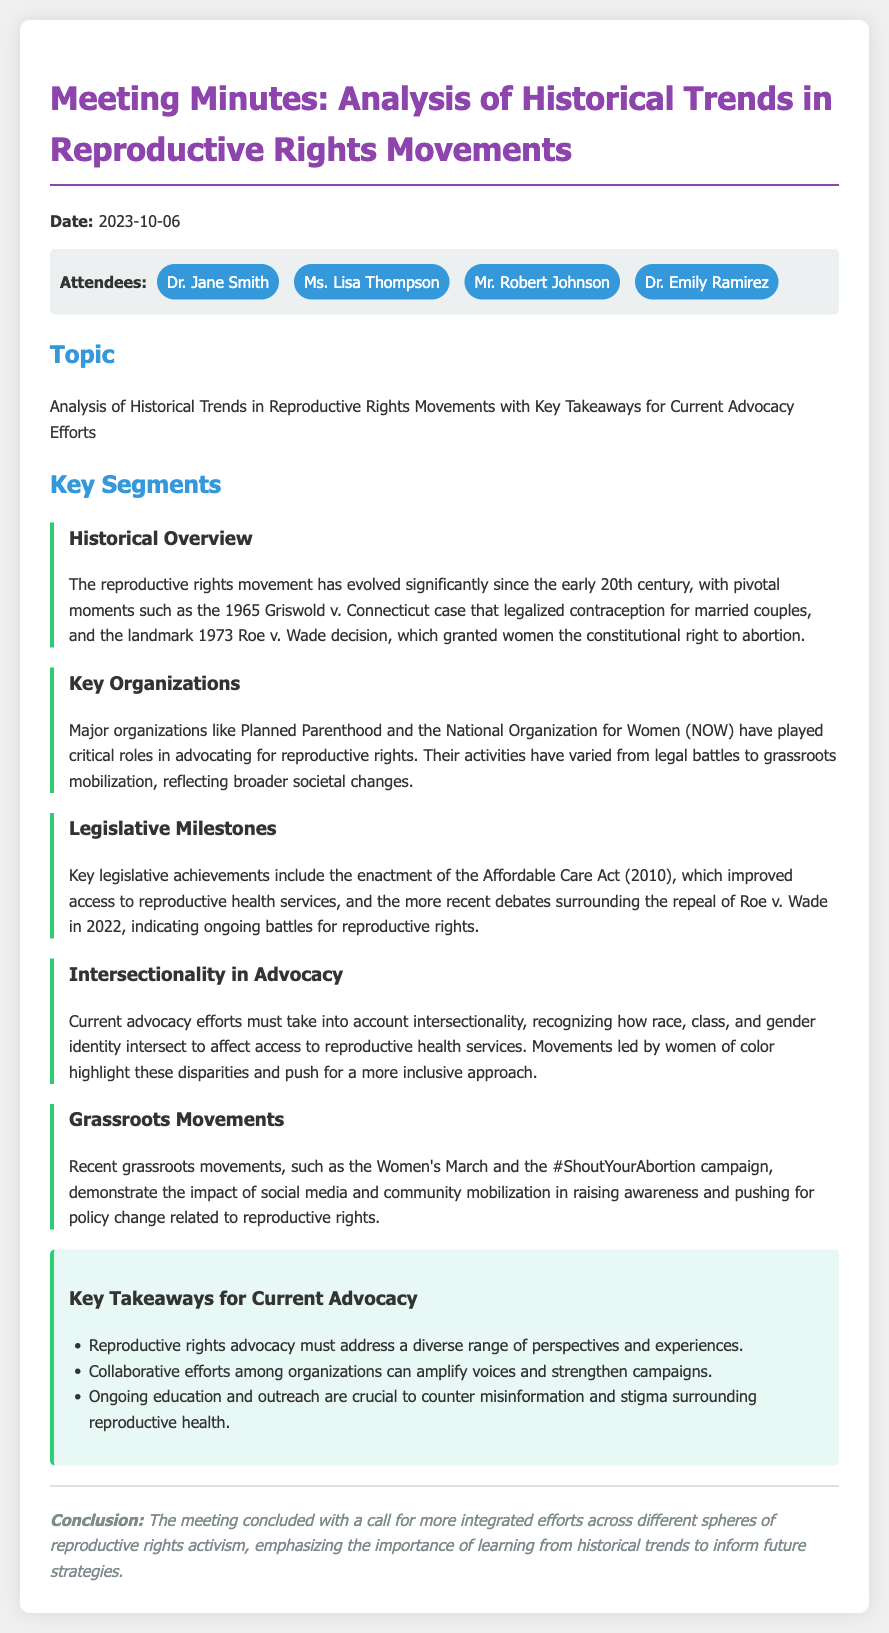What was the date of the meeting? The document states the meeting date as 2023-10-06.
Answer: 2023-10-06 Who attended the meeting? The attendees are listed in the document as Dr. Jane Smith, Ms. Lisa Thompson, Mr. Robert Johnson, and Dr. Emily Ramirez.
Answer: Dr. Jane Smith, Ms. Lisa Thompson, Mr. Robert Johnson, Dr. Emily Ramirez What landmark case legalized contraception for married couples? The document mentions the Griswold v. Connecticut case as pivotal for legalizing contraception.
Answer: Griswold v. Connecticut What significant act was enacted in 2010 related to reproductive rights? The Affordable Care Act, which improved access to reproductive health services, is noted in the document.
Answer: Affordable Care Act What do current advocacy efforts need to consider according to the document? The document emphasizes that current advocacy must take into account intersectionality.
Answer: Intersectionality What campaign highlights the role of social media in reproductive rights? The #ShoutYourAbortion campaign is mentioned as an impactful grassroots movement using social media.
Answer: #ShoutYourAbortion What is one key takeaway for current advocacy efforts? The document lists that reproductive rights advocacy must address a diverse range of perspectives and experiences.
Answer: Diverse perspectives What type of advocacy work is critical according to the meeting's conclusion? The conclusion calls for integrated efforts across different spheres of reproductive rights activism.
Answer: Integrated efforts What milestone decision was made regarding abortion in 1973? The document refers to the Roe v. Wade decision which granted women the constitutional right to abortion.
Answer: Roe v. Wade 